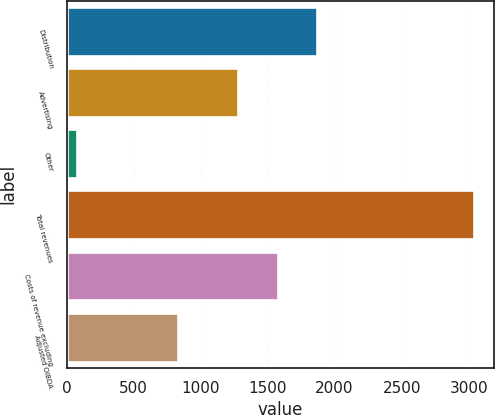<chart> <loc_0><loc_0><loc_500><loc_500><bar_chart><fcel>Distribution<fcel>Advertising<fcel>Other<fcel>Total revenues<fcel>Costs of revenue excluding<fcel>Adjusted OIBDA<nl><fcel>1871<fcel>1279<fcel>80<fcel>3040<fcel>1575<fcel>835<nl></chart> 